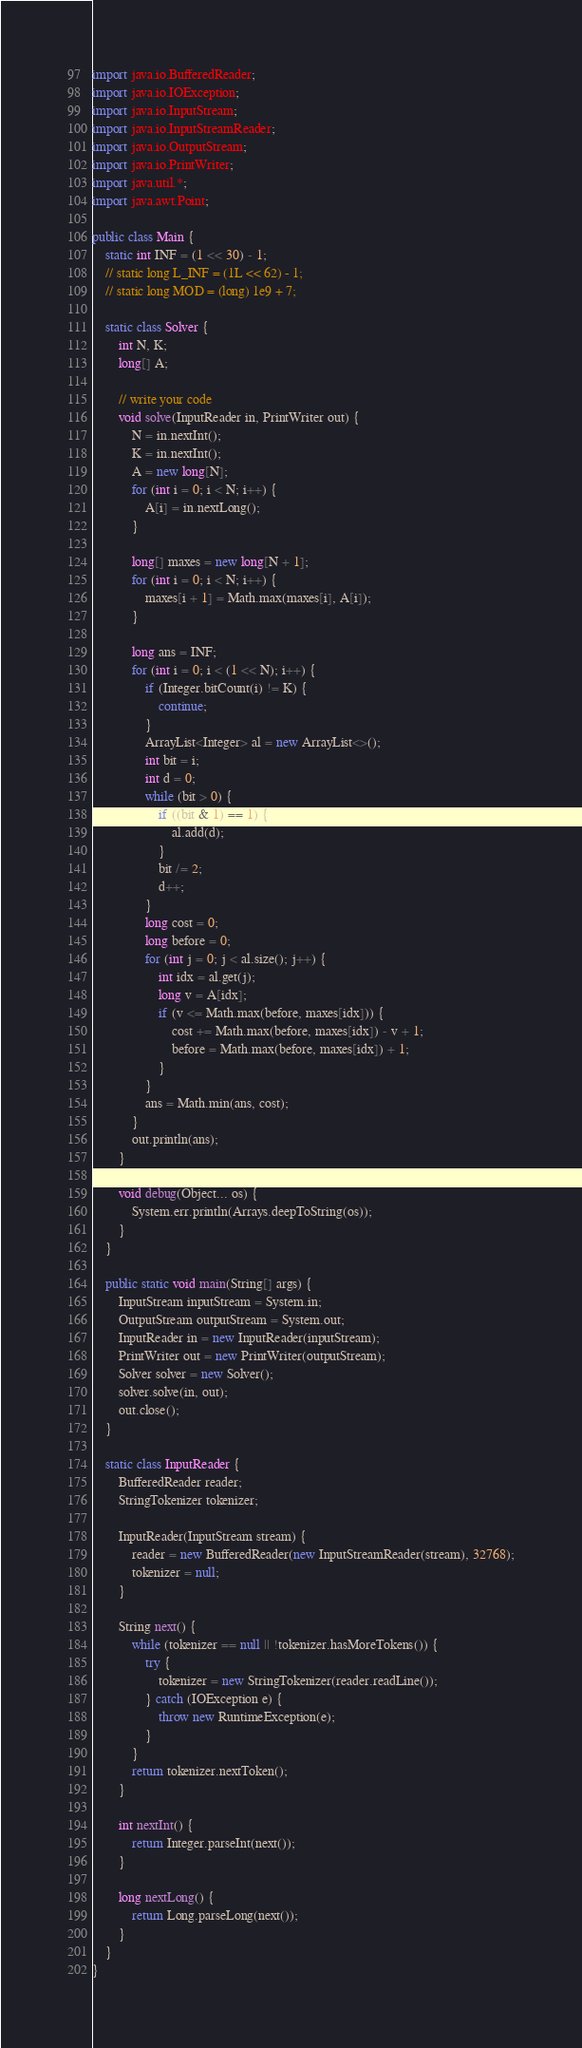Convert code to text. <code><loc_0><loc_0><loc_500><loc_500><_Java_>import java.io.BufferedReader;
import java.io.IOException;
import java.io.InputStream;
import java.io.InputStreamReader;
import java.io.OutputStream;
import java.io.PrintWriter;
import java.util.*;
import java.awt.Point;

public class Main {
    static int INF = (1 << 30) - 1;
    // static long L_INF = (1L << 62) - 1;
    // static long MOD = (long) 1e9 + 7;

    static class Solver {
        int N, K;
        long[] A;

        // write your code
        void solve(InputReader in, PrintWriter out) {
            N = in.nextInt();
            K = in.nextInt();
            A = new long[N];
            for (int i = 0; i < N; i++) {
                A[i] = in.nextLong();
            }

            long[] maxes = new long[N + 1];
            for (int i = 0; i < N; i++) {
                maxes[i + 1] = Math.max(maxes[i], A[i]);
            }

            long ans = INF;
            for (int i = 0; i < (1 << N); i++) {
                if (Integer.bitCount(i) != K) {
                    continue;
                }
                ArrayList<Integer> al = new ArrayList<>();
                int bit = i;
                int d = 0;
                while (bit > 0) {
                    if ((bit & 1) == 1) {
                        al.add(d);
                    }
                    bit /= 2;
                    d++;
                }
                long cost = 0;
                long before = 0;
                for (int j = 0; j < al.size(); j++) {
                    int idx = al.get(j);
                    long v = A[idx];
                    if (v <= Math.max(before, maxes[idx])) {
                        cost += Math.max(before, maxes[idx]) - v + 1;
                        before = Math.max(before, maxes[idx]) + 1;
                    }
                }
                ans = Math.min(ans, cost);
            }
            out.println(ans);
        }

        void debug(Object... os) {
            System.err.println(Arrays.deepToString(os));
        }
    }

    public static void main(String[] args) {
        InputStream inputStream = System.in;
        OutputStream outputStream = System.out;
        InputReader in = new InputReader(inputStream);
        PrintWriter out = new PrintWriter(outputStream);
        Solver solver = new Solver();
        solver.solve(in, out);
        out.close();
    }

    static class InputReader {
        BufferedReader reader;
        StringTokenizer tokenizer;

        InputReader(InputStream stream) {
            reader = new BufferedReader(new InputStreamReader(stream), 32768);
            tokenizer = null;
        }

        String next() {
            while (tokenizer == null || !tokenizer.hasMoreTokens()) {
                try {
                    tokenizer = new StringTokenizer(reader.readLine());
                } catch (IOException e) {
                    throw new RuntimeException(e);
                }
            }
            return tokenizer.nextToken();
        }

        int nextInt() {
            return Integer.parseInt(next());
        }

        long nextLong() {
            return Long.parseLong(next());
        }
    }
}
</code> 